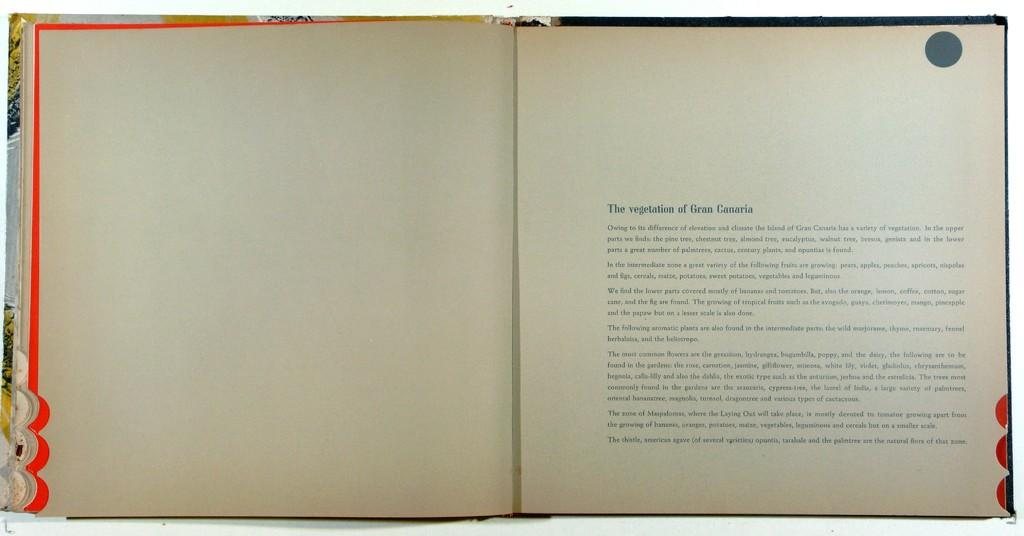<image>
Create a compact narrative representing the image presented. a room page that says 'the vegetation of gran canaria' as the title of the page 